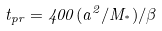<formula> <loc_0><loc_0><loc_500><loc_500>t _ { p r } = 4 0 0 ( a ^ { 2 } / M _ { ^ { * } } ) / \beta</formula> 